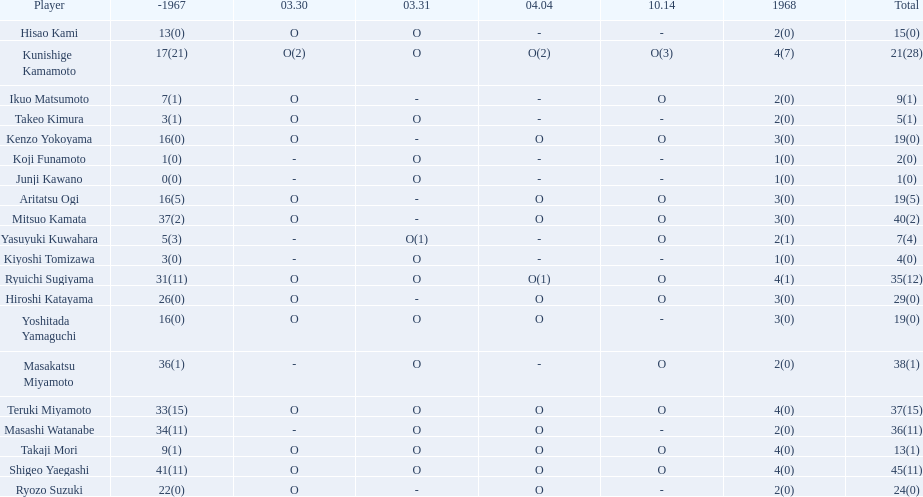How many more total appearances did shigeo yaegashi have than mitsuo kamata? 5. 